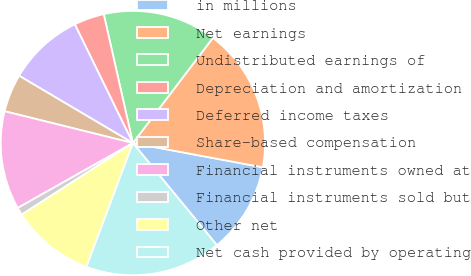Convert chart. <chart><loc_0><loc_0><loc_500><loc_500><pie_chart><fcel>in millions<fcel>Net earnings<fcel>Undistributed earnings of<fcel>Depreciation and amortization<fcel>Deferred income taxes<fcel>Share-based compensation<fcel>Financial instruments owned at<fcel>Financial instruments sold but<fcel>Other net<fcel>Net cash provided by operating<nl><fcel>11.11%<fcel>17.59%<fcel>13.89%<fcel>3.7%<fcel>9.26%<fcel>4.63%<fcel>12.04%<fcel>0.93%<fcel>10.19%<fcel>16.67%<nl></chart> 